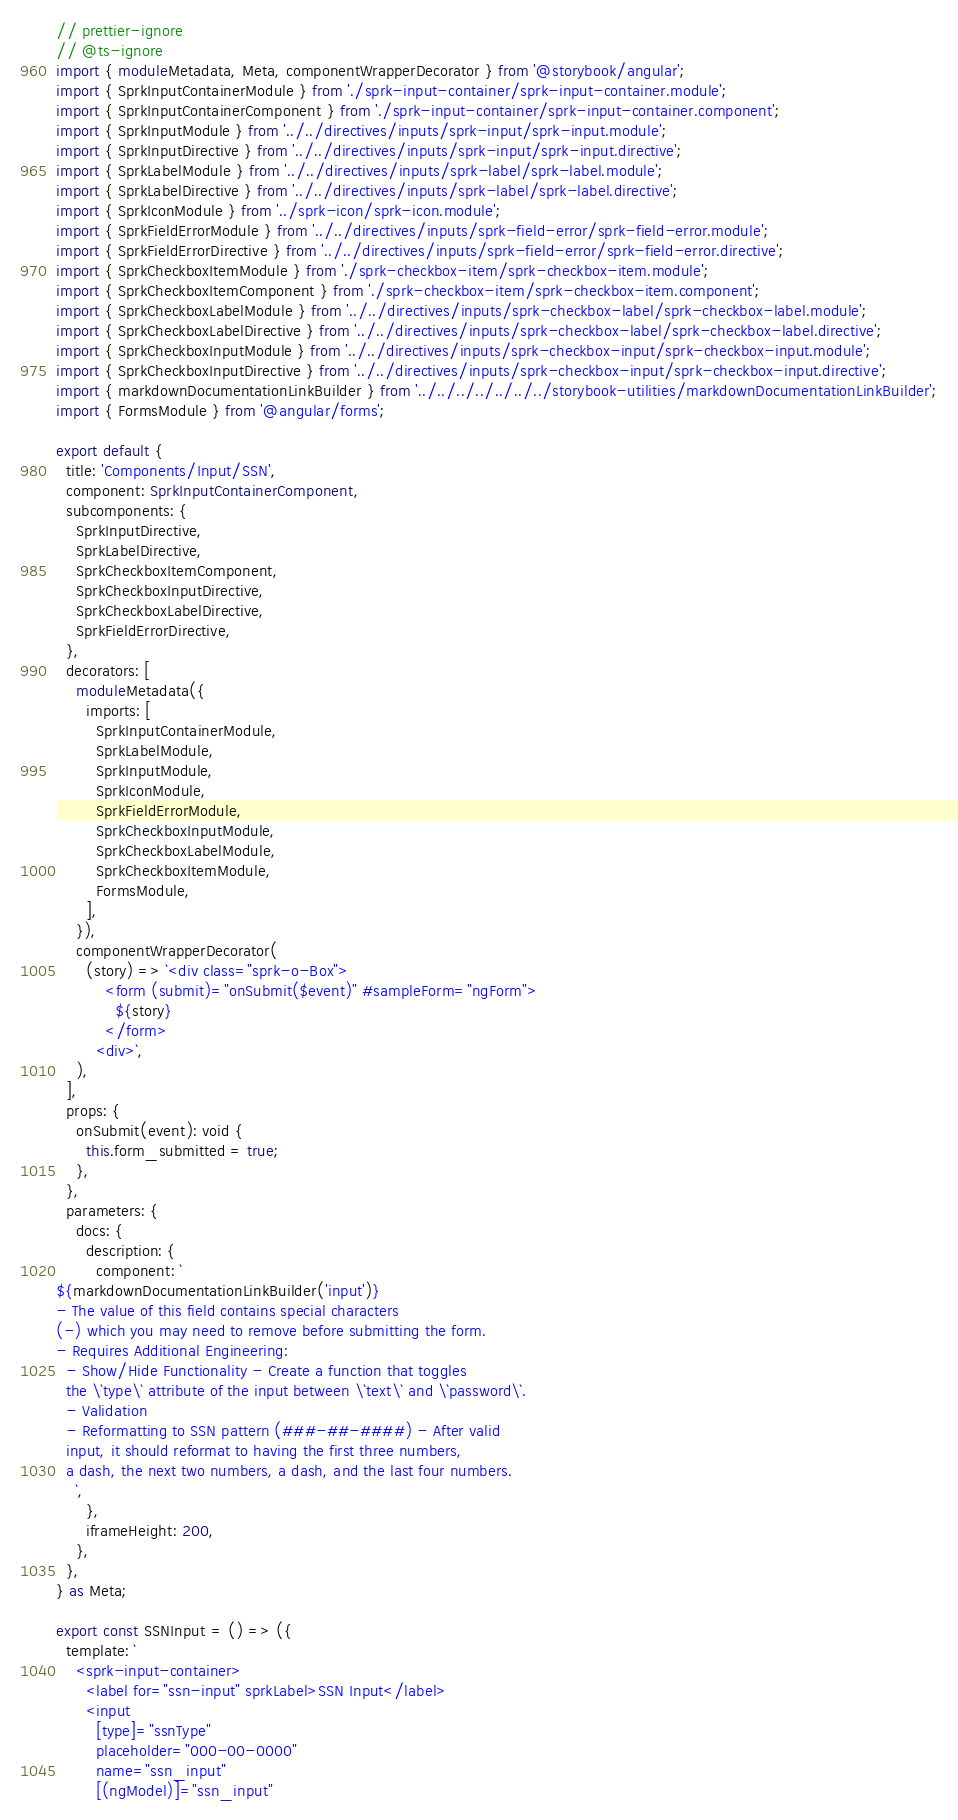Convert code to text. <code><loc_0><loc_0><loc_500><loc_500><_TypeScript_>// prettier-ignore
// @ts-ignore
import { moduleMetadata, Meta, componentWrapperDecorator } from '@storybook/angular';
import { SprkInputContainerModule } from './sprk-input-container/sprk-input-container.module';
import { SprkInputContainerComponent } from './sprk-input-container/sprk-input-container.component';
import { SprkInputModule } from '../../directives/inputs/sprk-input/sprk-input.module';
import { SprkInputDirective } from '../../directives/inputs/sprk-input/sprk-input.directive';
import { SprkLabelModule } from '../../directives/inputs/sprk-label/sprk-label.module';
import { SprkLabelDirective } from '../../directives/inputs/sprk-label/sprk-label.directive';
import { SprkIconModule } from '../sprk-icon/sprk-icon.module';
import { SprkFieldErrorModule } from '../../directives/inputs/sprk-field-error/sprk-field-error.module';
import { SprkFieldErrorDirective } from '../../directives/inputs/sprk-field-error/sprk-field-error.directive';
import { SprkCheckboxItemModule } from './sprk-checkbox-item/sprk-checkbox-item.module';
import { SprkCheckboxItemComponent } from './sprk-checkbox-item/sprk-checkbox-item.component';
import { SprkCheckboxLabelModule } from '../../directives/inputs/sprk-checkbox-label/sprk-checkbox-label.module';
import { SprkCheckboxLabelDirective } from '../../directives/inputs/sprk-checkbox-label/sprk-checkbox-label.directive';
import { SprkCheckboxInputModule } from '../../directives/inputs/sprk-checkbox-input/sprk-checkbox-input.module';
import { SprkCheckboxInputDirective } from '../../directives/inputs/sprk-checkbox-input/sprk-checkbox-input.directive';
import { markdownDocumentationLinkBuilder } from '../../../../../../../storybook-utilities/markdownDocumentationLinkBuilder';
import { FormsModule } from '@angular/forms';

export default {
  title: 'Components/Input/SSN',
  component: SprkInputContainerComponent,
  subcomponents: {
    SprkInputDirective,
    SprkLabelDirective,
    SprkCheckboxItemComponent,
    SprkCheckboxInputDirective,
    SprkCheckboxLabelDirective,
    SprkFieldErrorDirective,
  },
  decorators: [
    moduleMetadata({
      imports: [
        SprkInputContainerModule,
        SprkLabelModule,
        SprkInputModule,
        SprkIconModule,
        SprkFieldErrorModule,
        SprkCheckboxInputModule,
        SprkCheckboxLabelModule,
        SprkCheckboxItemModule,
        FormsModule,
      ],
    }),
    componentWrapperDecorator(
      (story) => `<div class="sprk-o-Box">
          <form (submit)="onSubmit($event)" #sampleForm="ngForm">
            ${story}
          </form>
        <div>`,
    ),
  ],
  props: {
    onSubmit(event): void {
      this.form_submitted = true;
    },
  },
  parameters: {
    docs: {
      description: {
        component: `
${markdownDocumentationLinkBuilder('input')}
- The value of this field contains special characters
(-) which you may need to remove before submitting the form.
- Requires Additional Engineering:
  - Show/Hide Functionality - Create a function that toggles
  the \`type\` attribute of the input between \`text\` and \`password\`.
  - Validation
  - Reformatting to SSN pattern (###-##-####) - After valid
  input, it should reformat to having the first three numbers,
  a dash, the next two numbers, a dash, and the last four numbers.
    `,
      },
      iframeHeight: 200,
    },
  },
} as Meta;

export const SSNInput = () => ({
  template: `
    <sprk-input-container>
      <label for="ssn-input" sprkLabel>SSN Input</label>
      <input
        [type]="ssnType"
        placeholder="000-00-0000"
        name="ssn_input"
        [(ngModel)]="ssn_input"</code> 